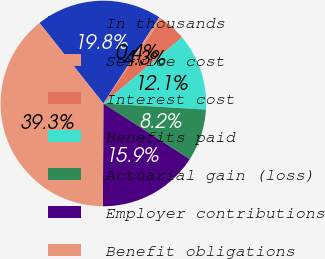Convert chart. <chart><loc_0><loc_0><loc_500><loc_500><pie_chart><fcel>In thousands<fcel>Service cost<fcel>Interest cost<fcel>Benefits paid<fcel>Actuarial gain (loss)<fcel>Employer contributions<fcel>Benefit obligations<nl><fcel>19.84%<fcel>0.41%<fcel>4.3%<fcel>12.07%<fcel>8.18%<fcel>15.95%<fcel>39.26%<nl></chart> 